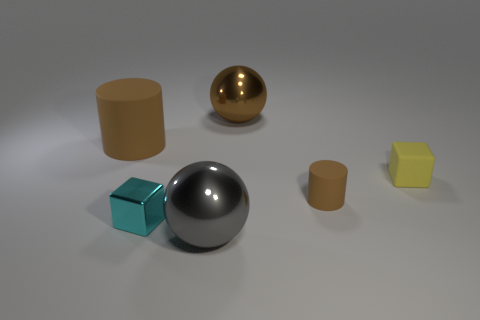Add 3 small cyan metal blocks. How many objects exist? 9 Subtract 1 cylinders. How many cylinders are left? 1 Subtract all yellow blocks. How many blocks are left? 1 Subtract all spheres. How many objects are left? 4 Add 6 metallic cubes. How many metallic cubes are left? 7 Add 3 tiny green things. How many tiny green things exist? 3 Subtract 0 gray cylinders. How many objects are left? 6 Subtract all gray balls. Subtract all yellow cylinders. How many balls are left? 1 Subtract all metallic spheres. Subtract all large brown cylinders. How many objects are left? 3 